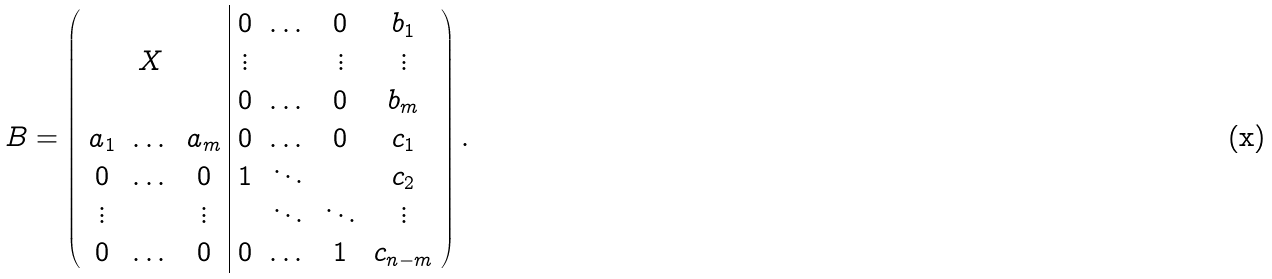Convert formula to latex. <formula><loc_0><loc_0><loc_500><loc_500>B = \left ( \begin{array} { c c c | c c c c } & & & 0 & \dots & 0 & b _ { 1 } \\ & X & & \vdots & & \vdots & \vdots \\ & & & 0 & \dots & 0 & b _ { m } \\ a _ { 1 } & \dots & a _ { m } & 0 & \dots & 0 & c _ { 1 } \\ 0 & \dots & 0 & 1 & \ddots & & c _ { 2 } \\ \vdots & & \vdots & & \ddots & \ddots & \vdots \\ 0 & \dots & 0 & 0 & \dots & 1 & c _ { n - m } \end{array} \right ) .</formula> 